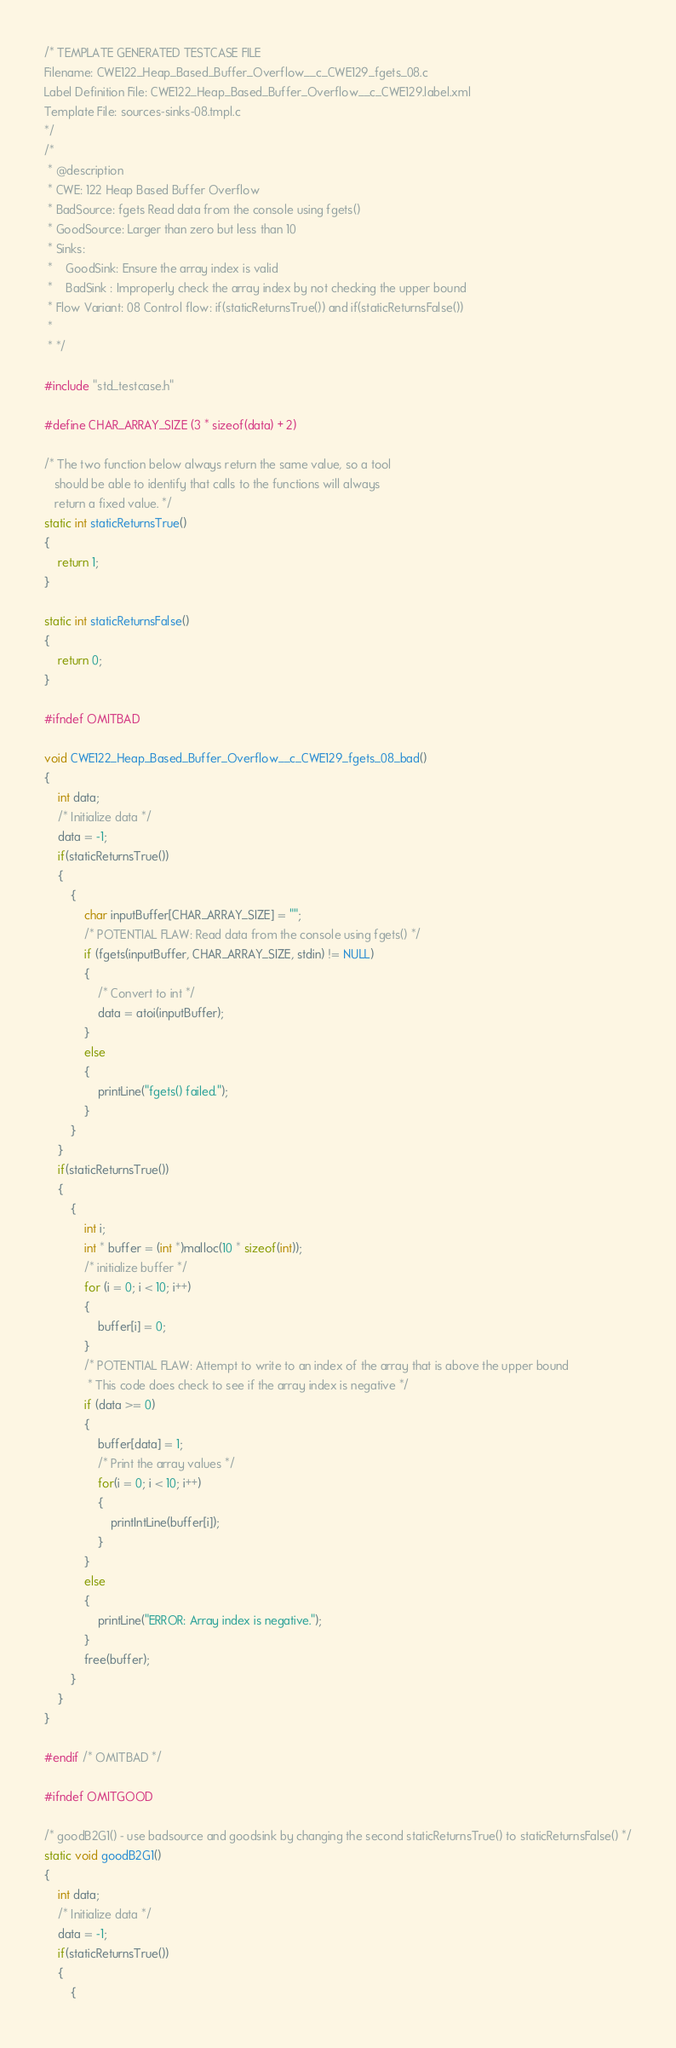<code> <loc_0><loc_0><loc_500><loc_500><_C_>/* TEMPLATE GENERATED TESTCASE FILE
Filename: CWE122_Heap_Based_Buffer_Overflow__c_CWE129_fgets_08.c
Label Definition File: CWE122_Heap_Based_Buffer_Overflow__c_CWE129.label.xml
Template File: sources-sinks-08.tmpl.c
*/
/*
 * @description
 * CWE: 122 Heap Based Buffer Overflow
 * BadSource: fgets Read data from the console using fgets()
 * GoodSource: Larger than zero but less than 10
 * Sinks:
 *    GoodSink: Ensure the array index is valid
 *    BadSink : Improperly check the array index by not checking the upper bound
 * Flow Variant: 08 Control flow: if(staticReturnsTrue()) and if(staticReturnsFalse())
 *
 * */

#include "std_testcase.h"

#define CHAR_ARRAY_SIZE (3 * sizeof(data) + 2)

/* The two function below always return the same value, so a tool
   should be able to identify that calls to the functions will always
   return a fixed value. */
static int staticReturnsTrue()
{
    return 1;
}

static int staticReturnsFalse()
{
    return 0;
}

#ifndef OMITBAD

void CWE122_Heap_Based_Buffer_Overflow__c_CWE129_fgets_08_bad()
{
    int data;
    /* Initialize data */
    data = -1;
    if(staticReturnsTrue())
    {
        {
            char inputBuffer[CHAR_ARRAY_SIZE] = "";
            /* POTENTIAL FLAW: Read data from the console using fgets() */
            if (fgets(inputBuffer, CHAR_ARRAY_SIZE, stdin) != NULL)
            {
                /* Convert to int */
                data = atoi(inputBuffer);
            }
            else
            {
                printLine("fgets() failed.");
            }
        }
    }
    if(staticReturnsTrue())
    {
        {
            int i;
            int * buffer = (int *)malloc(10 * sizeof(int));
            /* initialize buffer */
            for (i = 0; i < 10; i++)
            {
                buffer[i] = 0;
            }
            /* POTENTIAL FLAW: Attempt to write to an index of the array that is above the upper bound
             * This code does check to see if the array index is negative */
            if (data >= 0)
            {
                buffer[data] = 1;
                /* Print the array values */
                for(i = 0; i < 10; i++)
                {
                    printIntLine(buffer[i]);
                }
            }
            else
            {
                printLine("ERROR: Array index is negative.");
            }
            free(buffer);
        }
    }
}

#endif /* OMITBAD */

#ifndef OMITGOOD

/* goodB2G1() - use badsource and goodsink by changing the second staticReturnsTrue() to staticReturnsFalse() */
static void goodB2G1()
{
    int data;
    /* Initialize data */
    data = -1;
    if(staticReturnsTrue())
    {
        {</code> 